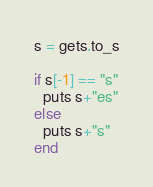Convert code to text. <code><loc_0><loc_0><loc_500><loc_500><_Ruby_>s = gets.to_s

if s[-1] == "s"
  puts s+"es"
else
  puts s+"s"
end</code> 